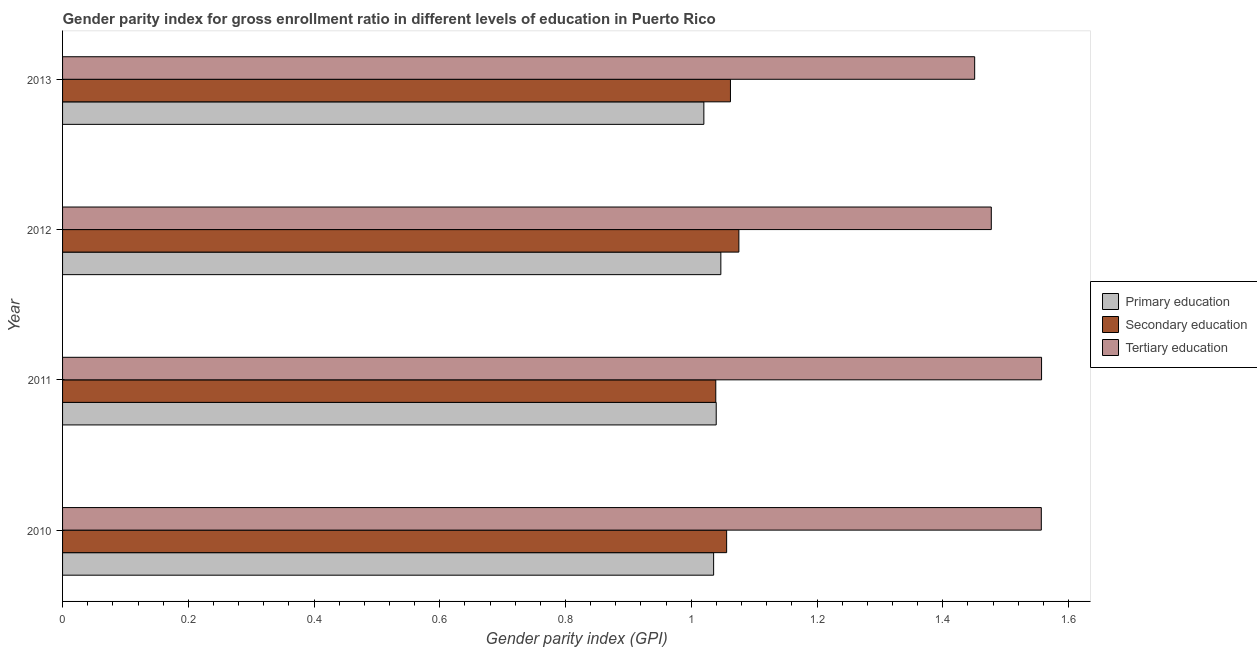How many groups of bars are there?
Provide a short and direct response. 4. How many bars are there on the 3rd tick from the bottom?
Offer a very short reply. 3. What is the label of the 2nd group of bars from the top?
Offer a terse response. 2012. What is the gender parity index in tertiary education in 2011?
Make the answer very short. 1.56. Across all years, what is the maximum gender parity index in primary education?
Give a very brief answer. 1.05. Across all years, what is the minimum gender parity index in primary education?
Make the answer very short. 1.02. In which year was the gender parity index in secondary education maximum?
Your answer should be compact. 2012. In which year was the gender parity index in tertiary education minimum?
Keep it short and to the point. 2013. What is the total gender parity index in primary education in the graph?
Your answer should be compact. 4.14. What is the difference between the gender parity index in secondary education in 2010 and that in 2013?
Give a very brief answer. -0.01. What is the difference between the gender parity index in tertiary education in 2010 and the gender parity index in primary education in 2012?
Keep it short and to the point. 0.51. What is the average gender parity index in secondary education per year?
Provide a short and direct response. 1.06. In the year 2010, what is the difference between the gender parity index in primary education and gender parity index in secondary education?
Your answer should be very brief. -0.02. In how many years, is the gender parity index in tertiary education greater than 0.9600000000000001 ?
Your response must be concise. 4. What is the ratio of the gender parity index in primary education in 2011 to that in 2013?
Offer a terse response. 1.02. Is the difference between the gender parity index in secondary education in 2012 and 2013 greater than the difference between the gender parity index in primary education in 2012 and 2013?
Your answer should be very brief. No. What is the difference between the highest and the second highest gender parity index in tertiary education?
Provide a succinct answer. 0. What is the difference between the highest and the lowest gender parity index in primary education?
Give a very brief answer. 0.03. Is it the case that in every year, the sum of the gender parity index in primary education and gender parity index in secondary education is greater than the gender parity index in tertiary education?
Provide a short and direct response. Yes. How many years are there in the graph?
Provide a short and direct response. 4. What is the difference between two consecutive major ticks on the X-axis?
Your answer should be very brief. 0.2. Are the values on the major ticks of X-axis written in scientific E-notation?
Your answer should be compact. No. Does the graph contain any zero values?
Offer a very short reply. No. How many legend labels are there?
Provide a succinct answer. 3. How are the legend labels stacked?
Provide a succinct answer. Vertical. What is the title of the graph?
Your answer should be compact. Gender parity index for gross enrollment ratio in different levels of education in Puerto Rico. What is the label or title of the X-axis?
Ensure brevity in your answer.  Gender parity index (GPI). What is the Gender parity index (GPI) of Primary education in 2010?
Your response must be concise. 1.04. What is the Gender parity index (GPI) of Secondary education in 2010?
Your response must be concise. 1.06. What is the Gender parity index (GPI) in Tertiary education in 2010?
Keep it short and to the point. 1.56. What is the Gender parity index (GPI) of Primary education in 2011?
Keep it short and to the point. 1.04. What is the Gender parity index (GPI) in Secondary education in 2011?
Offer a very short reply. 1.04. What is the Gender parity index (GPI) of Tertiary education in 2011?
Give a very brief answer. 1.56. What is the Gender parity index (GPI) of Primary education in 2012?
Give a very brief answer. 1.05. What is the Gender parity index (GPI) in Secondary education in 2012?
Your response must be concise. 1.08. What is the Gender parity index (GPI) of Tertiary education in 2012?
Your response must be concise. 1.48. What is the Gender parity index (GPI) in Primary education in 2013?
Provide a succinct answer. 1.02. What is the Gender parity index (GPI) in Secondary education in 2013?
Keep it short and to the point. 1.06. What is the Gender parity index (GPI) in Tertiary education in 2013?
Ensure brevity in your answer.  1.45. Across all years, what is the maximum Gender parity index (GPI) of Primary education?
Your answer should be compact. 1.05. Across all years, what is the maximum Gender parity index (GPI) in Secondary education?
Provide a succinct answer. 1.08. Across all years, what is the maximum Gender parity index (GPI) in Tertiary education?
Offer a terse response. 1.56. Across all years, what is the minimum Gender parity index (GPI) in Primary education?
Offer a terse response. 1.02. Across all years, what is the minimum Gender parity index (GPI) in Secondary education?
Offer a terse response. 1.04. Across all years, what is the minimum Gender parity index (GPI) of Tertiary education?
Your response must be concise. 1.45. What is the total Gender parity index (GPI) in Primary education in the graph?
Give a very brief answer. 4.14. What is the total Gender parity index (GPI) in Secondary education in the graph?
Provide a succinct answer. 4.23. What is the total Gender parity index (GPI) in Tertiary education in the graph?
Give a very brief answer. 6.04. What is the difference between the Gender parity index (GPI) in Primary education in 2010 and that in 2011?
Your answer should be very brief. -0. What is the difference between the Gender parity index (GPI) in Secondary education in 2010 and that in 2011?
Your response must be concise. 0.02. What is the difference between the Gender parity index (GPI) in Tertiary education in 2010 and that in 2011?
Your answer should be very brief. -0. What is the difference between the Gender parity index (GPI) of Primary education in 2010 and that in 2012?
Your response must be concise. -0.01. What is the difference between the Gender parity index (GPI) of Secondary education in 2010 and that in 2012?
Your response must be concise. -0.02. What is the difference between the Gender parity index (GPI) of Tertiary education in 2010 and that in 2012?
Provide a short and direct response. 0.08. What is the difference between the Gender parity index (GPI) of Primary education in 2010 and that in 2013?
Your answer should be compact. 0.02. What is the difference between the Gender parity index (GPI) in Secondary education in 2010 and that in 2013?
Your answer should be compact. -0.01. What is the difference between the Gender parity index (GPI) of Tertiary education in 2010 and that in 2013?
Your answer should be compact. 0.11. What is the difference between the Gender parity index (GPI) of Primary education in 2011 and that in 2012?
Provide a succinct answer. -0.01. What is the difference between the Gender parity index (GPI) of Secondary education in 2011 and that in 2012?
Ensure brevity in your answer.  -0.04. What is the difference between the Gender parity index (GPI) of Tertiary education in 2011 and that in 2012?
Provide a succinct answer. 0.08. What is the difference between the Gender parity index (GPI) in Primary education in 2011 and that in 2013?
Provide a short and direct response. 0.02. What is the difference between the Gender parity index (GPI) of Secondary education in 2011 and that in 2013?
Give a very brief answer. -0.02. What is the difference between the Gender parity index (GPI) in Tertiary education in 2011 and that in 2013?
Your answer should be compact. 0.11. What is the difference between the Gender parity index (GPI) in Primary education in 2012 and that in 2013?
Offer a very short reply. 0.03. What is the difference between the Gender parity index (GPI) in Secondary education in 2012 and that in 2013?
Provide a succinct answer. 0.01. What is the difference between the Gender parity index (GPI) in Tertiary education in 2012 and that in 2013?
Your answer should be compact. 0.03. What is the difference between the Gender parity index (GPI) of Primary education in 2010 and the Gender parity index (GPI) of Secondary education in 2011?
Your answer should be very brief. -0. What is the difference between the Gender parity index (GPI) of Primary education in 2010 and the Gender parity index (GPI) of Tertiary education in 2011?
Provide a short and direct response. -0.52. What is the difference between the Gender parity index (GPI) in Secondary education in 2010 and the Gender parity index (GPI) in Tertiary education in 2011?
Your response must be concise. -0.5. What is the difference between the Gender parity index (GPI) of Primary education in 2010 and the Gender parity index (GPI) of Secondary education in 2012?
Make the answer very short. -0.04. What is the difference between the Gender parity index (GPI) in Primary education in 2010 and the Gender parity index (GPI) in Tertiary education in 2012?
Ensure brevity in your answer.  -0.44. What is the difference between the Gender parity index (GPI) in Secondary education in 2010 and the Gender parity index (GPI) in Tertiary education in 2012?
Offer a very short reply. -0.42. What is the difference between the Gender parity index (GPI) in Primary education in 2010 and the Gender parity index (GPI) in Secondary education in 2013?
Your answer should be very brief. -0.03. What is the difference between the Gender parity index (GPI) of Primary education in 2010 and the Gender parity index (GPI) of Tertiary education in 2013?
Your answer should be compact. -0.42. What is the difference between the Gender parity index (GPI) in Secondary education in 2010 and the Gender parity index (GPI) in Tertiary education in 2013?
Ensure brevity in your answer.  -0.39. What is the difference between the Gender parity index (GPI) of Primary education in 2011 and the Gender parity index (GPI) of Secondary education in 2012?
Offer a terse response. -0.04. What is the difference between the Gender parity index (GPI) of Primary education in 2011 and the Gender parity index (GPI) of Tertiary education in 2012?
Offer a terse response. -0.44. What is the difference between the Gender parity index (GPI) of Secondary education in 2011 and the Gender parity index (GPI) of Tertiary education in 2012?
Offer a very short reply. -0.44. What is the difference between the Gender parity index (GPI) in Primary education in 2011 and the Gender parity index (GPI) in Secondary education in 2013?
Provide a short and direct response. -0.02. What is the difference between the Gender parity index (GPI) of Primary education in 2011 and the Gender parity index (GPI) of Tertiary education in 2013?
Offer a very short reply. -0.41. What is the difference between the Gender parity index (GPI) in Secondary education in 2011 and the Gender parity index (GPI) in Tertiary education in 2013?
Offer a very short reply. -0.41. What is the difference between the Gender parity index (GPI) of Primary education in 2012 and the Gender parity index (GPI) of Secondary education in 2013?
Ensure brevity in your answer.  -0.02. What is the difference between the Gender parity index (GPI) of Primary education in 2012 and the Gender parity index (GPI) of Tertiary education in 2013?
Your answer should be compact. -0.4. What is the difference between the Gender parity index (GPI) in Secondary education in 2012 and the Gender parity index (GPI) in Tertiary education in 2013?
Your response must be concise. -0.38. What is the average Gender parity index (GPI) of Primary education per year?
Your answer should be very brief. 1.04. What is the average Gender parity index (GPI) in Secondary education per year?
Offer a terse response. 1.06. What is the average Gender parity index (GPI) in Tertiary education per year?
Ensure brevity in your answer.  1.51. In the year 2010, what is the difference between the Gender parity index (GPI) in Primary education and Gender parity index (GPI) in Secondary education?
Offer a very short reply. -0.02. In the year 2010, what is the difference between the Gender parity index (GPI) of Primary education and Gender parity index (GPI) of Tertiary education?
Provide a succinct answer. -0.52. In the year 2010, what is the difference between the Gender parity index (GPI) in Secondary education and Gender parity index (GPI) in Tertiary education?
Offer a terse response. -0.5. In the year 2011, what is the difference between the Gender parity index (GPI) in Primary education and Gender parity index (GPI) in Secondary education?
Your response must be concise. 0. In the year 2011, what is the difference between the Gender parity index (GPI) in Primary education and Gender parity index (GPI) in Tertiary education?
Keep it short and to the point. -0.52. In the year 2011, what is the difference between the Gender parity index (GPI) of Secondary education and Gender parity index (GPI) of Tertiary education?
Give a very brief answer. -0.52. In the year 2012, what is the difference between the Gender parity index (GPI) of Primary education and Gender parity index (GPI) of Secondary education?
Your answer should be very brief. -0.03. In the year 2012, what is the difference between the Gender parity index (GPI) of Primary education and Gender parity index (GPI) of Tertiary education?
Keep it short and to the point. -0.43. In the year 2012, what is the difference between the Gender parity index (GPI) in Secondary education and Gender parity index (GPI) in Tertiary education?
Your answer should be compact. -0.4. In the year 2013, what is the difference between the Gender parity index (GPI) of Primary education and Gender parity index (GPI) of Secondary education?
Offer a terse response. -0.04. In the year 2013, what is the difference between the Gender parity index (GPI) in Primary education and Gender parity index (GPI) in Tertiary education?
Ensure brevity in your answer.  -0.43. In the year 2013, what is the difference between the Gender parity index (GPI) in Secondary education and Gender parity index (GPI) in Tertiary education?
Ensure brevity in your answer.  -0.39. What is the ratio of the Gender parity index (GPI) of Primary education in 2010 to that in 2011?
Keep it short and to the point. 1. What is the ratio of the Gender parity index (GPI) of Secondary education in 2010 to that in 2011?
Offer a terse response. 1.02. What is the ratio of the Gender parity index (GPI) of Primary education in 2010 to that in 2012?
Your answer should be very brief. 0.99. What is the ratio of the Gender parity index (GPI) in Secondary education in 2010 to that in 2012?
Keep it short and to the point. 0.98. What is the ratio of the Gender parity index (GPI) of Tertiary education in 2010 to that in 2012?
Offer a very short reply. 1.05. What is the ratio of the Gender parity index (GPI) of Primary education in 2010 to that in 2013?
Your answer should be very brief. 1.02. What is the ratio of the Gender parity index (GPI) in Secondary education in 2010 to that in 2013?
Keep it short and to the point. 0.99. What is the ratio of the Gender parity index (GPI) in Tertiary education in 2010 to that in 2013?
Make the answer very short. 1.07. What is the ratio of the Gender parity index (GPI) of Primary education in 2011 to that in 2012?
Provide a succinct answer. 0.99. What is the ratio of the Gender parity index (GPI) of Secondary education in 2011 to that in 2012?
Your response must be concise. 0.97. What is the ratio of the Gender parity index (GPI) of Tertiary education in 2011 to that in 2012?
Give a very brief answer. 1.05. What is the ratio of the Gender parity index (GPI) in Primary education in 2011 to that in 2013?
Your answer should be very brief. 1.02. What is the ratio of the Gender parity index (GPI) of Secondary education in 2011 to that in 2013?
Offer a very short reply. 0.98. What is the ratio of the Gender parity index (GPI) in Tertiary education in 2011 to that in 2013?
Make the answer very short. 1.07. What is the ratio of the Gender parity index (GPI) of Primary education in 2012 to that in 2013?
Keep it short and to the point. 1.03. What is the ratio of the Gender parity index (GPI) of Secondary education in 2012 to that in 2013?
Your answer should be very brief. 1.01. What is the ratio of the Gender parity index (GPI) in Tertiary education in 2012 to that in 2013?
Your answer should be compact. 1.02. What is the difference between the highest and the second highest Gender parity index (GPI) of Primary education?
Your response must be concise. 0.01. What is the difference between the highest and the second highest Gender parity index (GPI) of Secondary education?
Provide a succinct answer. 0.01. What is the difference between the highest and the lowest Gender parity index (GPI) of Primary education?
Your answer should be very brief. 0.03. What is the difference between the highest and the lowest Gender parity index (GPI) of Secondary education?
Ensure brevity in your answer.  0.04. What is the difference between the highest and the lowest Gender parity index (GPI) in Tertiary education?
Your answer should be compact. 0.11. 